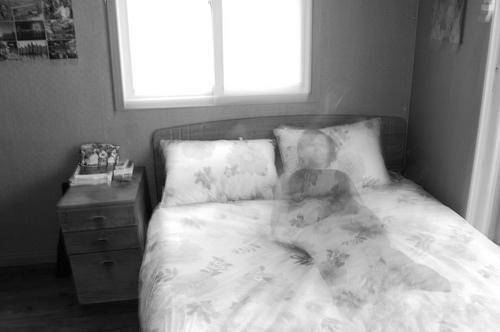How many pillows are on the bed?
Give a very brief answer. 2. 